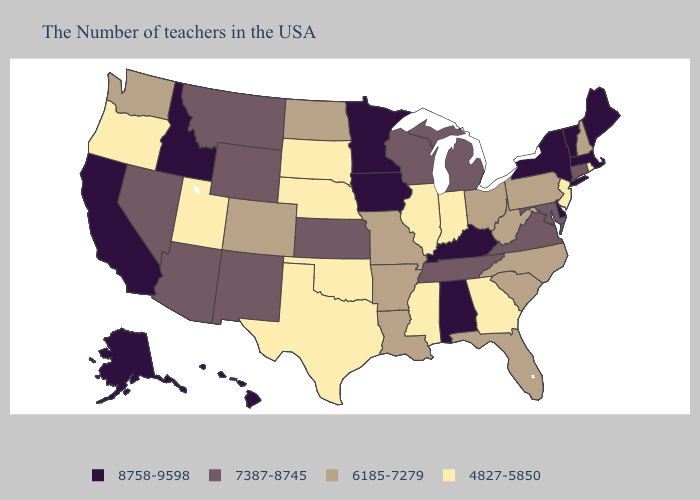Name the states that have a value in the range 4827-5850?
Write a very short answer. Rhode Island, New Jersey, Georgia, Indiana, Illinois, Mississippi, Nebraska, Oklahoma, Texas, South Dakota, Utah, Oregon. Name the states that have a value in the range 6185-7279?
Keep it brief. New Hampshire, Pennsylvania, North Carolina, South Carolina, West Virginia, Ohio, Florida, Louisiana, Missouri, Arkansas, North Dakota, Colorado, Washington. Does Virginia have the lowest value in the USA?
Keep it brief. No. Among the states that border Mississippi , which have the lowest value?
Write a very short answer. Louisiana, Arkansas. What is the value of New Hampshire?
Short answer required. 6185-7279. Is the legend a continuous bar?
Short answer required. No. What is the lowest value in the West?
Be succinct. 4827-5850. What is the value of Colorado?
Be succinct. 6185-7279. Does the first symbol in the legend represent the smallest category?
Quick response, please. No. Name the states that have a value in the range 8758-9598?
Answer briefly. Maine, Massachusetts, Vermont, New York, Delaware, Kentucky, Alabama, Minnesota, Iowa, Idaho, California, Alaska, Hawaii. Does the first symbol in the legend represent the smallest category?
Short answer required. No. Name the states that have a value in the range 7387-8745?
Short answer required. Connecticut, Maryland, Virginia, Michigan, Tennessee, Wisconsin, Kansas, Wyoming, New Mexico, Montana, Arizona, Nevada. Does Illinois have the highest value in the MidWest?
Quick response, please. No. What is the value of Virginia?
Keep it brief. 7387-8745. Does Pennsylvania have the lowest value in the Northeast?
Concise answer only. No. 